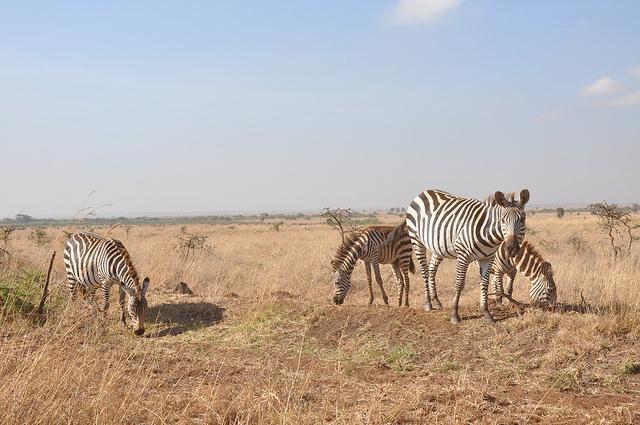How many zebras are standing together?
Give a very brief answer. 3. How many zebra have a shadow?
Give a very brief answer. 2. How many zebra are standing in this field?
Give a very brief answer. 4. How many zebras are there?
Give a very brief answer. 3. How many cows are laying down in this image?
Give a very brief answer. 0. 